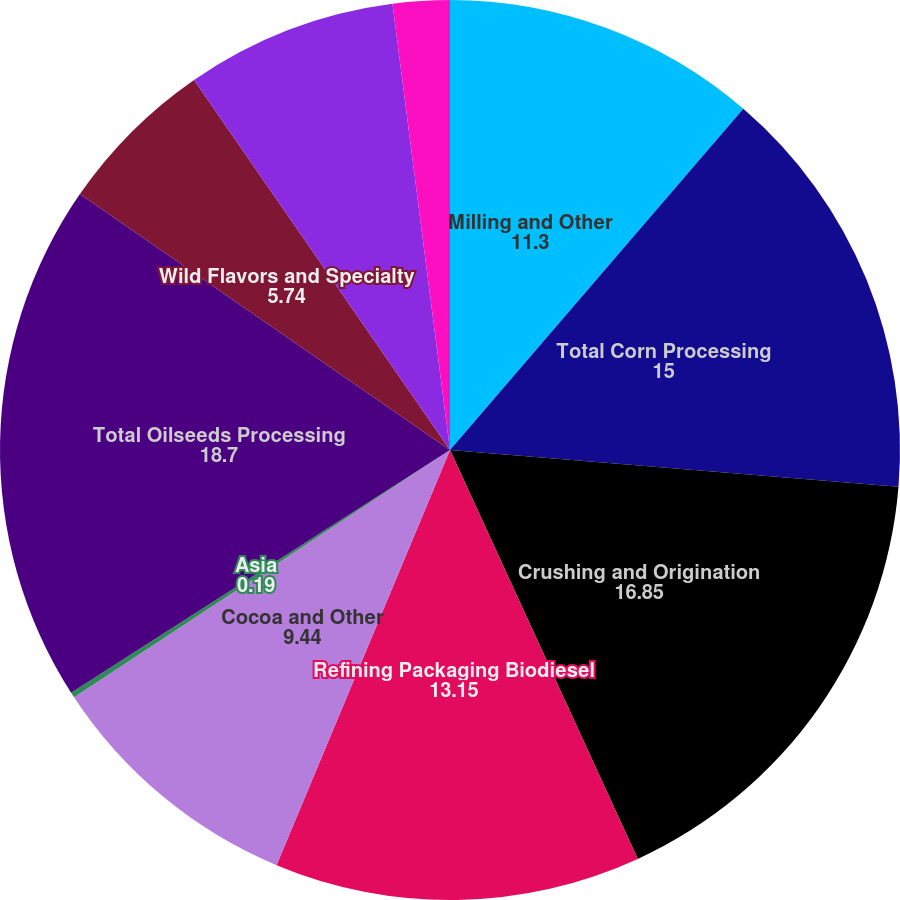<chart> <loc_0><loc_0><loc_500><loc_500><pie_chart><fcel>Milling and Other<fcel>Total Corn Processing<fcel>Crushing and Origination<fcel>Refining Packaging Biodiesel<fcel>Cocoa and Other<fcel>Asia<fcel>Total Oilseeds Processing<fcel>Wild Flavors and Specialty<fcel>Total Wild Flavors and<fcel>Other - Financial<nl><fcel>11.3%<fcel>15.0%<fcel>16.85%<fcel>13.15%<fcel>9.44%<fcel>0.19%<fcel>18.7%<fcel>5.74%<fcel>7.59%<fcel>2.04%<nl></chart> 